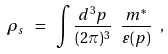<formula> <loc_0><loc_0><loc_500><loc_500>\rho _ { s } \ = \ \int \frac { d ^ { 3 } p } { ( 2 \pi ) ^ { 3 } } \ \frac { m ^ { * } } { \varepsilon ( p ) } \ ,</formula> 